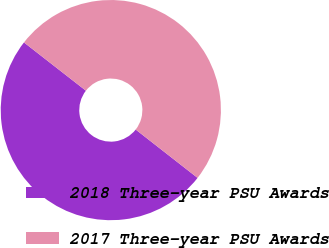Convert chart to OTSL. <chart><loc_0><loc_0><loc_500><loc_500><pie_chart><fcel>2018 Three-year PSU Awards<fcel>2017 Three-year PSU Awards<nl><fcel>49.98%<fcel>50.02%<nl></chart> 